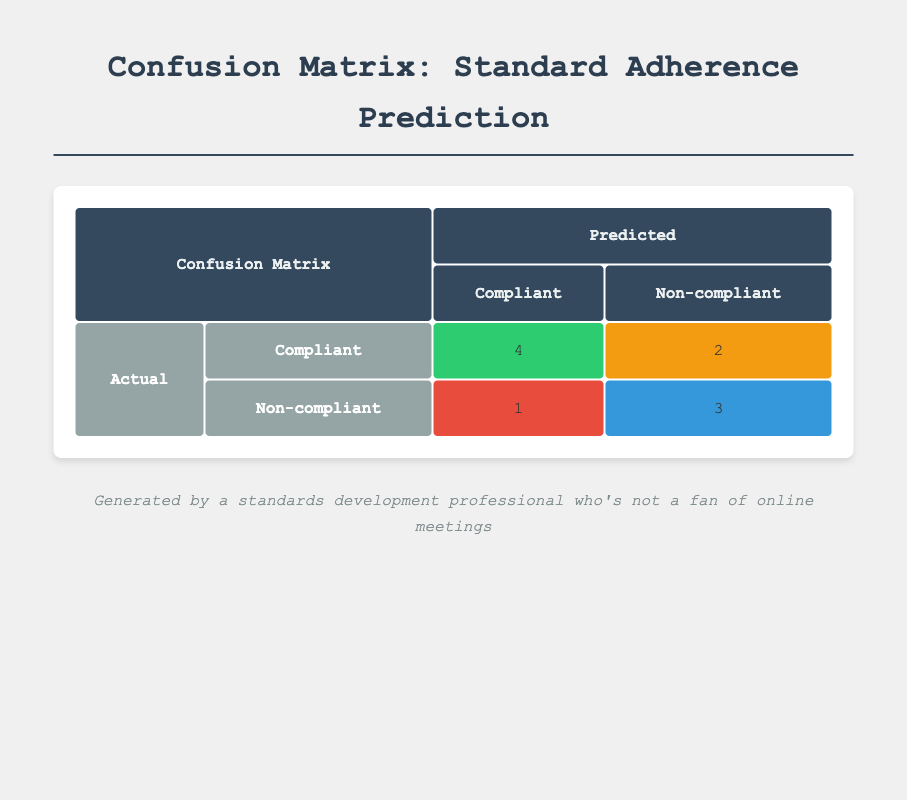What is the value for True Positive in the confusion matrix? The True Positive value is specifically stated in the table within the corresponding cell under the 'Compliant' predicted category and 'Compliant' actual category, which shows a value of 4.
Answer: 4 What is the total number of organizations that were predicted as Non-compliant? To find the total predicted as Non-compliant, we look at the two cells under the predicted Non-compliant column. Adding them gives us 1 (False Positive) + 2 (False Negative) = 3.
Answer: 3 How many organizations were correctly predicted as Compliant? The count of organizations correctly predicted as Compliant aligns with the True Positive value, which is 4 as per the table.
Answer: 4 What is the sum of False Positive and True Negative counts in the matrix? The False Positive count is 1, and the True Negative count is 3. Summing these values gives 1 + 3 = 4.
Answer: 4 Are there more True Negatives than False Negatives in the confusion matrix? The True Negative count is 3, and the False Negative count is 2. Since 3 is greater than 2, the answer is yes.
Answer: Yes What percentage of organizations are predicted correctly compared to actual Compliant organizations? The True Positive count is 4, while the total number of actual Compliant organizations is 6 (4 TP + 2 FN). To find the percentage, (4/6) * 100 = 66.67%.
Answer: 66.67% What is the ratio of False Negatives to True Positives? The False Negative count is 2, and the True Positive count is 4. The ratio is 2 to 4, which simplifies to 1 to 2.
Answer: 1 to 2 How many organizations were actually Non-compliant? To find this number, we check the counts in the actual Non-compliant row. The True Negative count is 3, and the False Positive count is 1. Summed up, we have 3 + 1 = 4 organizations that were actually Non-compliant.
Answer: 4 How many organizations were incorrectly predicted as Compliant? The number of organizations incorrectly predicted as Compliant corresponds to false positives, which is 1 according to the matrix.
Answer: 1 